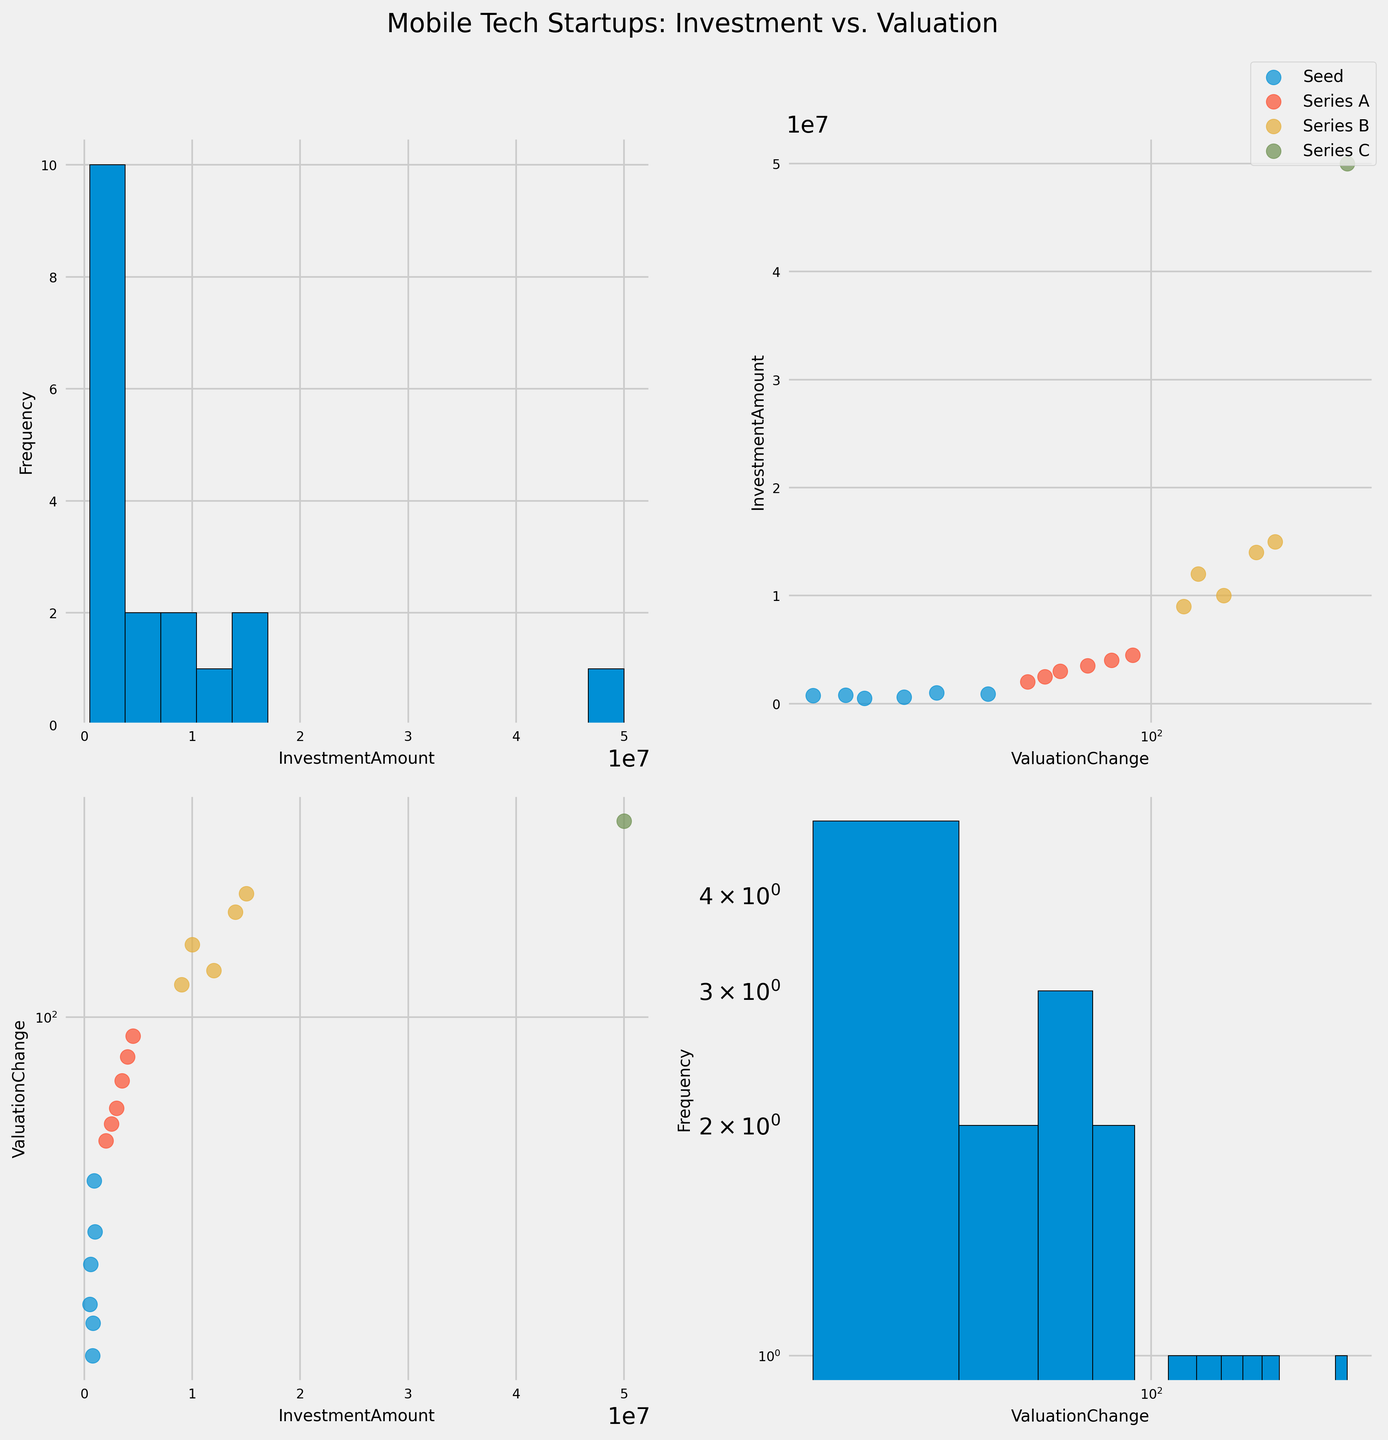How many different stages of funding are represented in the figure? To determine the number of stages, look at the distinct labels in the legend. These labels correspond to the various stages of funding. Identify and count each distinct stage.
Answer: 4 Which funding stage generally involves the highest investment amounts? Examine the scatter plots where 'InvestmentAmount' is on the y-axis. Identify the stage with higher data points on the y-axis.
Answer: Series C In which range do most 'ValuationChange' data points fall under the Series A funding stage? Check the color-coded scatter plot for Series A and observe the spread and density of data points along the 'ValuationChange' axis to find the common range.
Answer: 50-90 Which company exhibits the highest valuation change in the dataset? Look for the data point with the highest value on the 'ValuationChange' axis across all plots. Identify the associated company.
Answer: AppMingo Does the investment amount appear to increase logarithmically or linearly with the valuation change? Analyze the scatter plots that include 'InvestmentAmount' and 'ValuationChange'. Check for the adjusted axis scales and the spread and pattern of the data points to see if the relationship is logarithmic or linear.
Answer: Logarithmically How does the mean valuation change of Seed stage compare to that of Series B stage? Calculate the average valuation change for each stage by summing their valuation changes and dividing by the count of instances. Compare these averages for Seed and Series B.
Answer: Seed: ~24, Series B: ~155 Which stage shows the most variability in 'InvestmentAmount' values? Observe the scatter plots and note the spread of data points for 'InvestmentAmount' in each stage. Determine which stage has the widest spread.
Answer: Series B Is there a consistent trend in valuation change as funding stages progress from Seed to Series C? Track the pattern of changes in valuation from Seed to Series C using the scatter plots. Look for a consistent increase, decrease, or irregular pattern.
Answer: Consistent increase What is the frequency distribution of 'ValuationChange' values across all stages? Refer to the histogram of 'ValuationChange' values to observe the frequency distribution. Note where most of the data points fall.
Answer: Most values fall below 100 